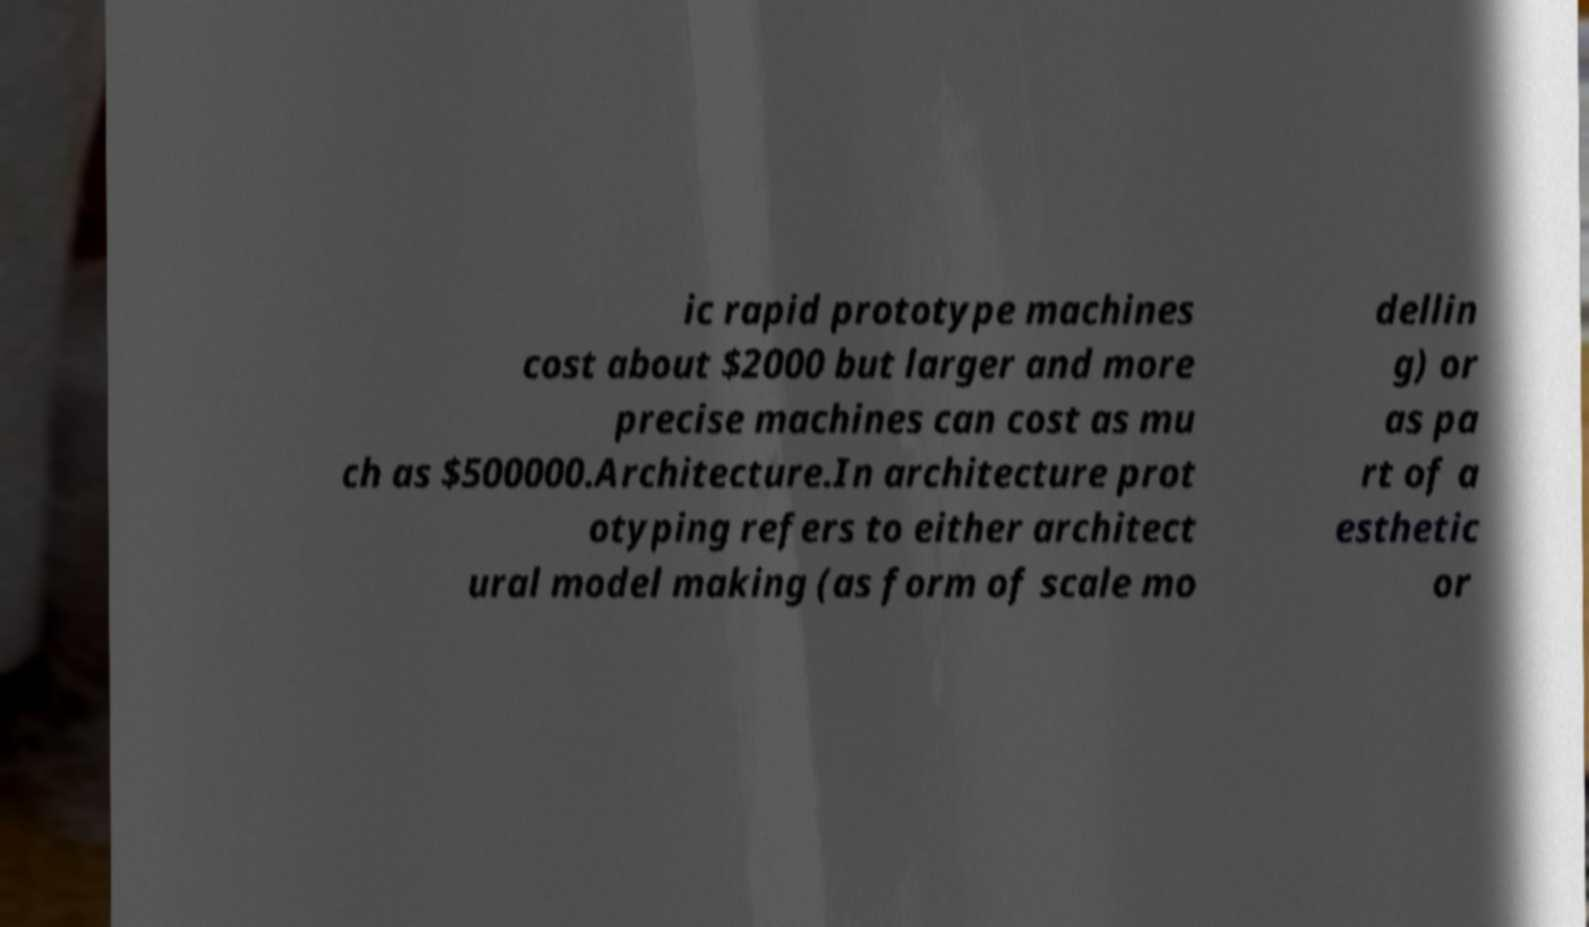Could you assist in decoding the text presented in this image and type it out clearly? ic rapid prototype machines cost about $2000 but larger and more precise machines can cost as mu ch as $500000.Architecture.In architecture prot otyping refers to either architect ural model making (as form of scale mo dellin g) or as pa rt of a esthetic or 